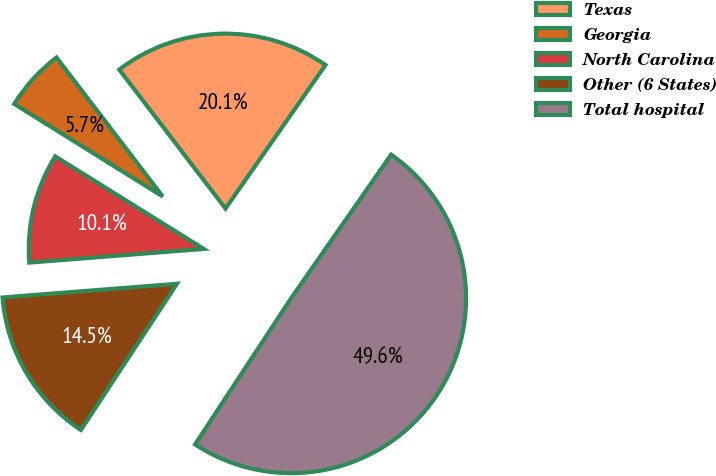Convert chart. <chart><loc_0><loc_0><loc_500><loc_500><pie_chart><fcel>Texas<fcel>Georgia<fcel>North Carolina<fcel>Other (6 States)<fcel>Total hospital<nl><fcel>20.07%<fcel>5.74%<fcel>10.12%<fcel>14.5%<fcel>49.57%<nl></chart> 